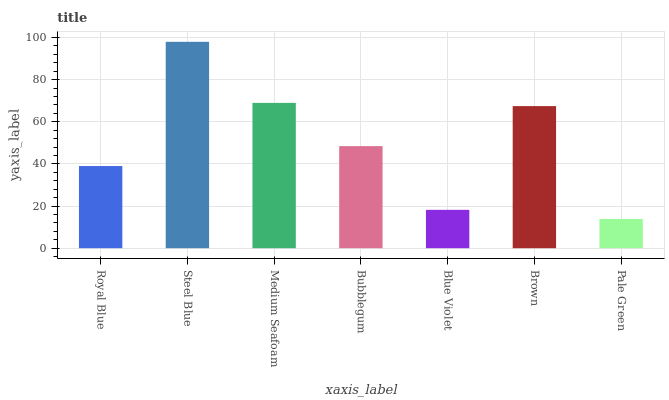Is Pale Green the minimum?
Answer yes or no. Yes. Is Steel Blue the maximum?
Answer yes or no. Yes. Is Medium Seafoam the minimum?
Answer yes or no. No. Is Medium Seafoam the maximum?
Answer yes or no. No. Is Steel Blue greater than Medium Seafoam?
Answer yes or no. Yes. Is Medium Seafoam less than Steel Blue?
Answer yes or no. Yes. Is Medium Seafoam greater than Steel Blue?
Answer yes or no. No. Is Steel Blue less than Medium Seafoam?
Answer yes or no. No. Is Bubblegum the high median?
Answer yes or no. Yes. Is Bubblegum the low median?
Answer yes or no. Yes. Is Medium Seafoam the high median?
Answer yes or no. No. Is Royal Blue the low median?
Answer yes or no. No. 